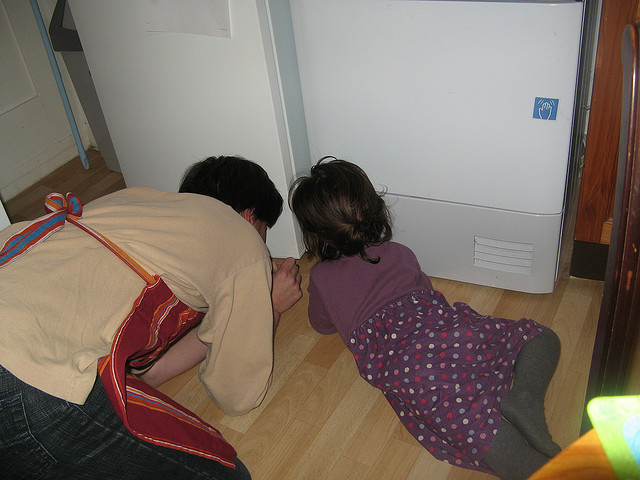<image>What is the pattern of the socks? I don't know the pattern of the socks. It can be either plain brown, solid, stripe, gray, diamond, or knit. What game are they playing? I am not sure what game they're playing. It can be marbles, refrigerator repair, dice, jacks, find ball, or nothing at all. What is the pattern of the socks? It is unclear what pattern the socks have. It can be seen 'plain brown', 'solid', 'stripe', 'plain' or 'diamond'. What game are they playing? I don't know what game they are playing. It can be marbles, refrigerator repair, dice, jacks, find ball or nothing. 